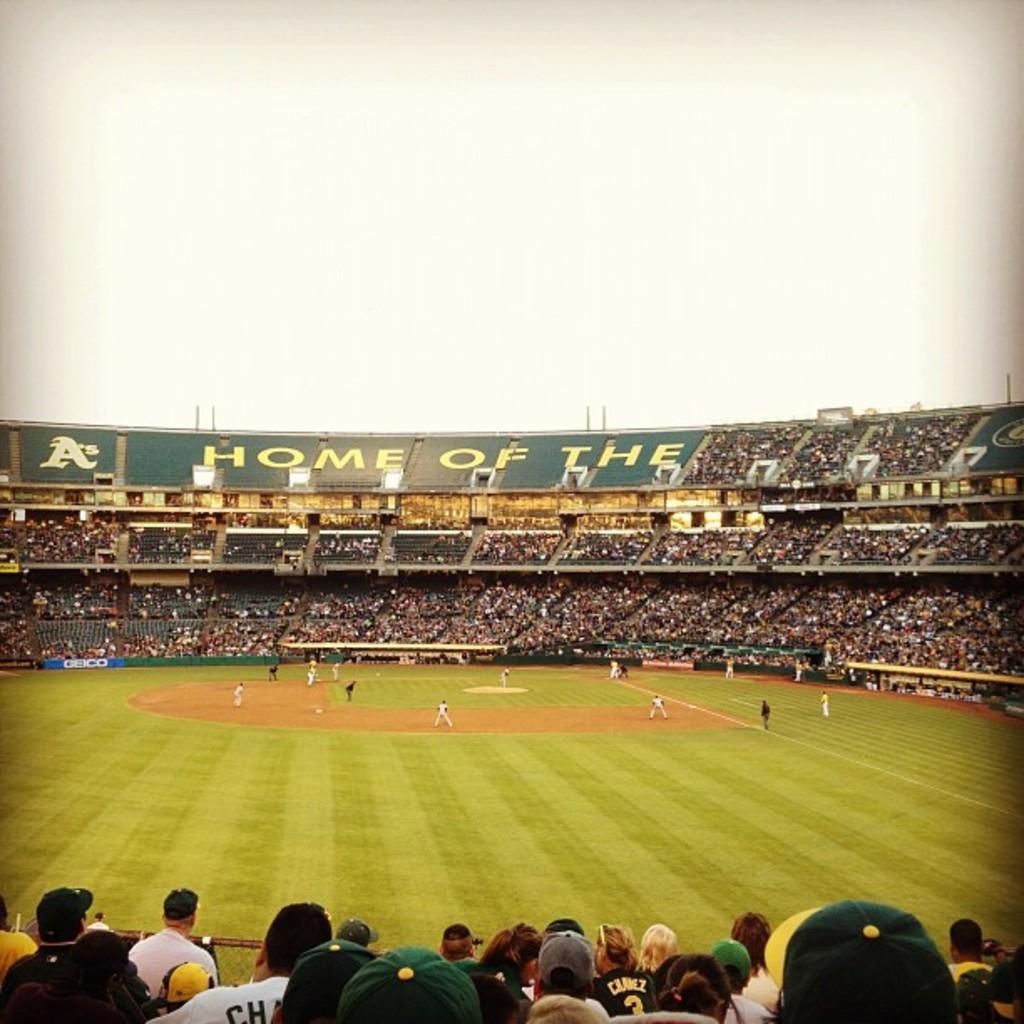What does it say in green?
Ensure brevity in your answer.  Home of the. What team is this for?
Your answer should be very brief. As. 